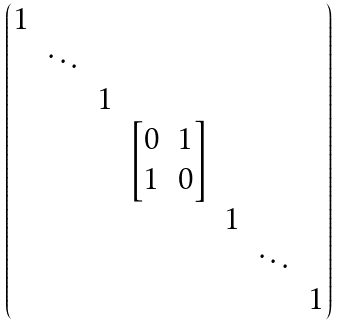Convert formula to latex. <formula><loc_0><loc_0><loc_500><loc_500>\begin{pmatrix} 1 & & & & & & \\ & \ddots & & & & & \\ & & 1 & & & & \\ & & & \begin{bmatrix} 0 & 1 \\ 1 & 0 \end{bmatrix} & & & \\ & & & & 1 & & \\ & & & & & \ddots & \\ & & & & & & 1 \end{pmatrix}</formula> 